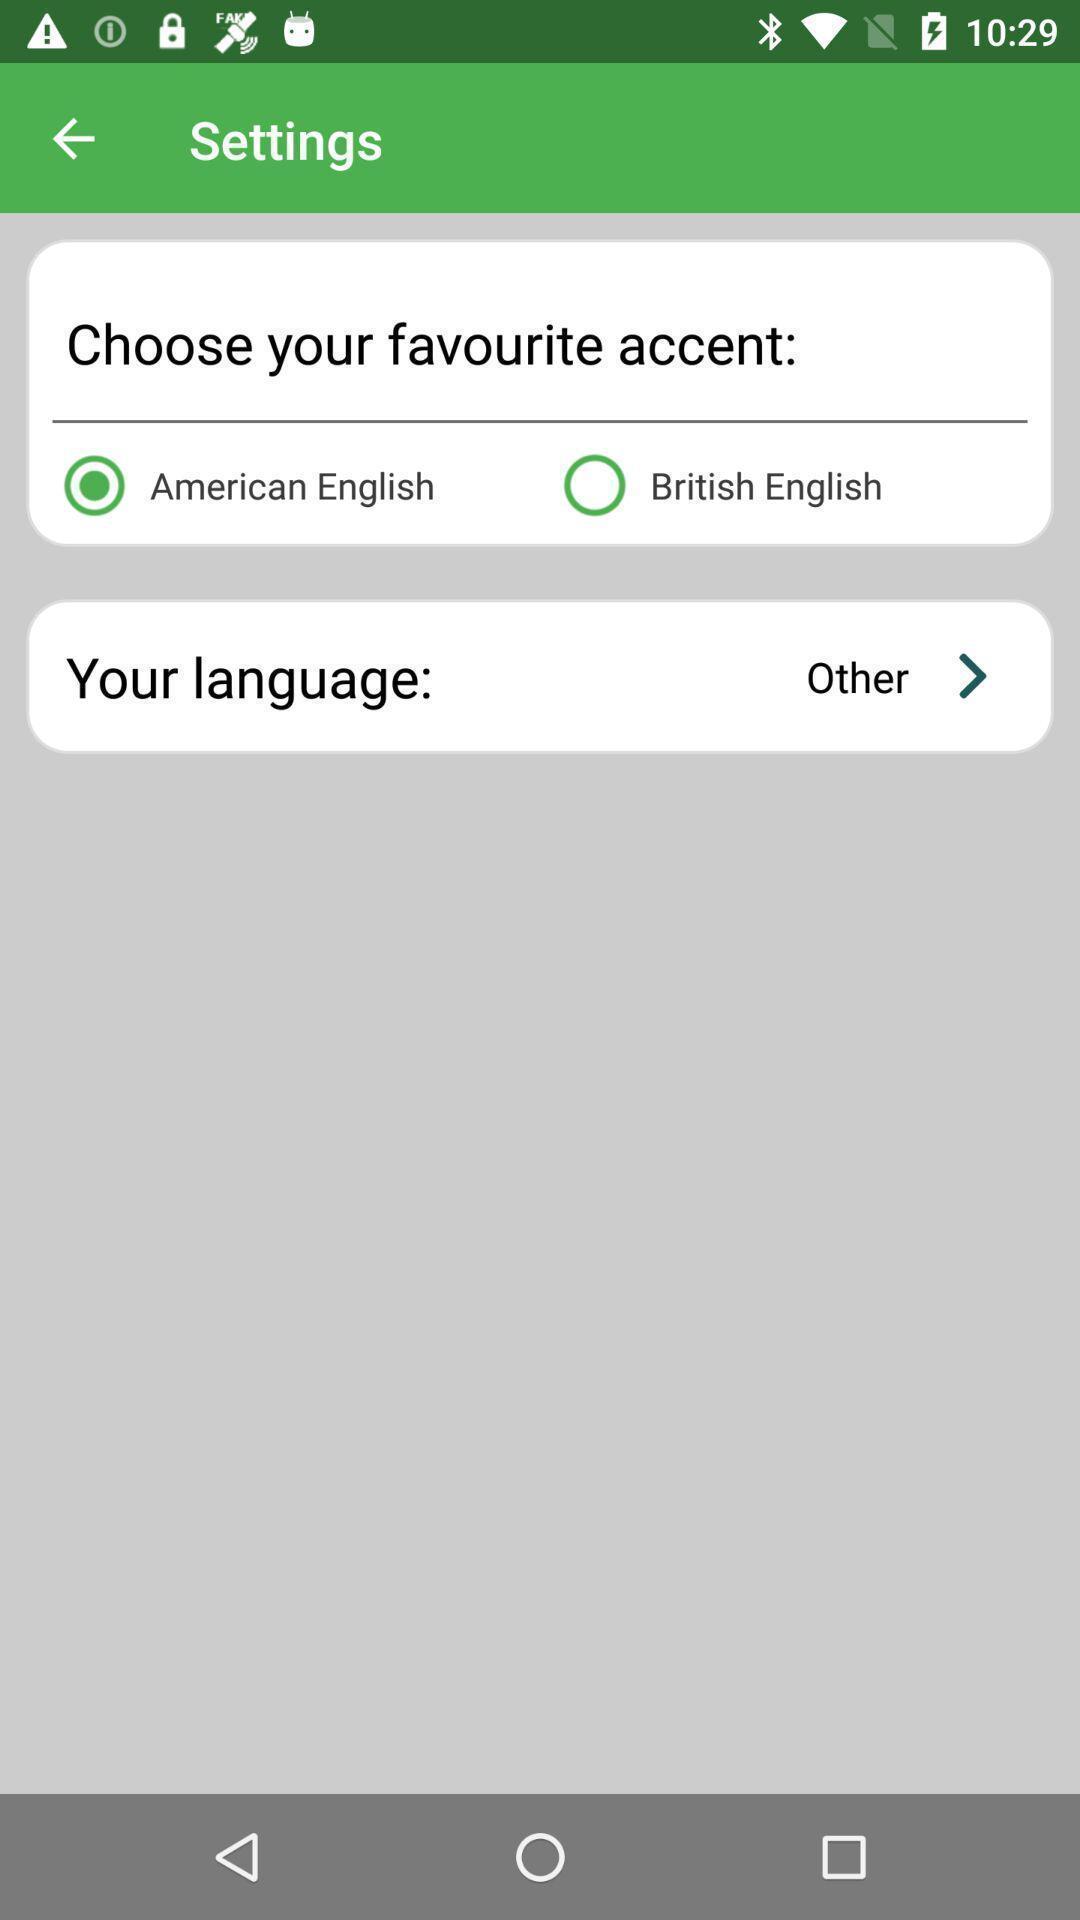Please provide a description for this image. Settings page with option to select accent. 